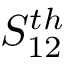<formula> <loc_0><loc_0><loc_500><loc_500>S _ { 1 2 } ^ { t h }</formula> 